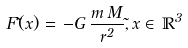<formula> <loc_0><loc_0><loc_500><loc_500>F ( \vec { x } ) = \, - G \, \frac { m \, M } { r ^ { 2 } } , \vec { x } \in \, \mathbb { R } ^ { 3 }</formula> 